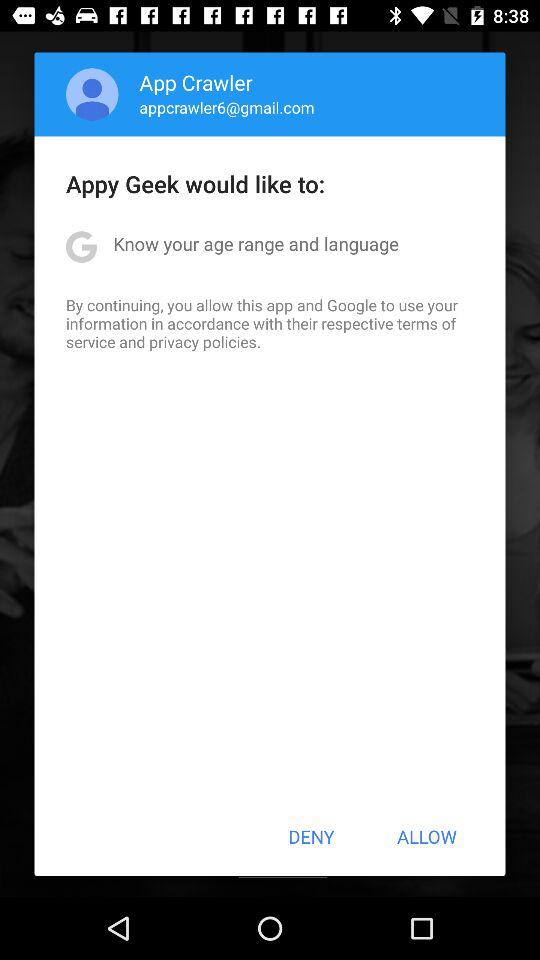What is the user name? The user name is App Crawler. 